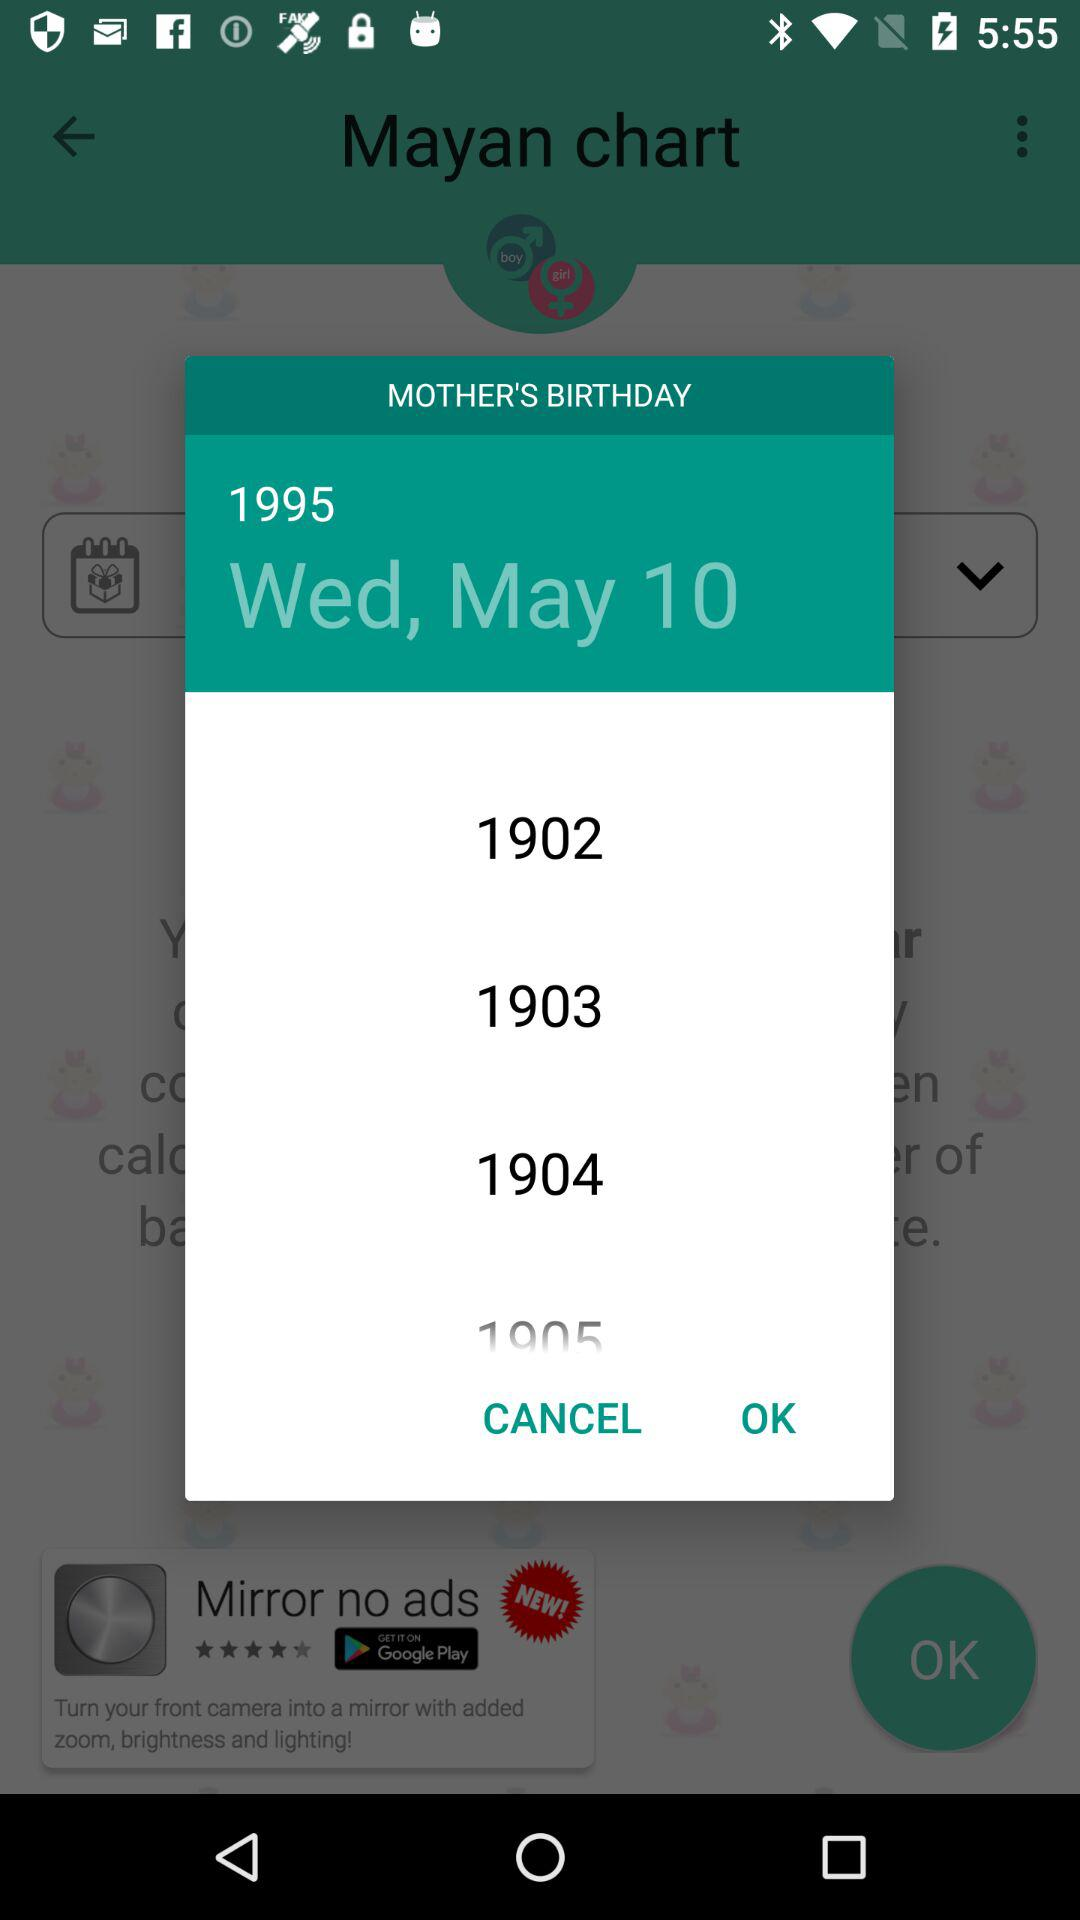What is the name of the application? The name of the application is "Baby Gender Predictor". 